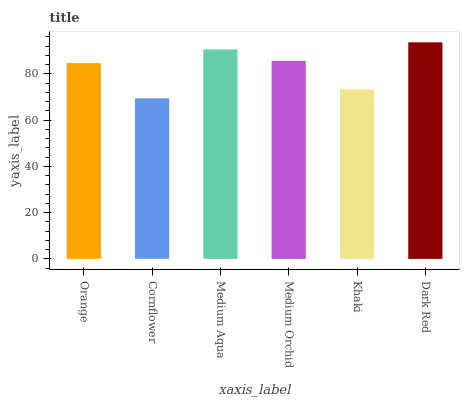Is Cornflower the minimum?
Answer yes or no. Yes. Is Dark Red the maximum?
Answer yes or no. Yes. Is Medium Aqua the minimum?
Answer yes or no. No. Is Medium Aqua the maximum?
Answer yes or no. No. Is Medium Aqua greater than Cornflower?
Answer yes or no. Yes. Is Cornflower less than Medium Aqua?
Answer yes or no. Yes. Is Cornflower greater than Medium Aqua?
Answer yes or no. No. Is Medium Aqua less than Cornflower?
Answer yes or no. No. Is Medium Orchid the high median?
Answer yes or no. Yes. Is Orange the low median?
Answer yes or no. Yes. Is Medium Aqua the high median?
Answer yes or no. No. Is Medium Orchid the low median?
Answer yes or no. No. 